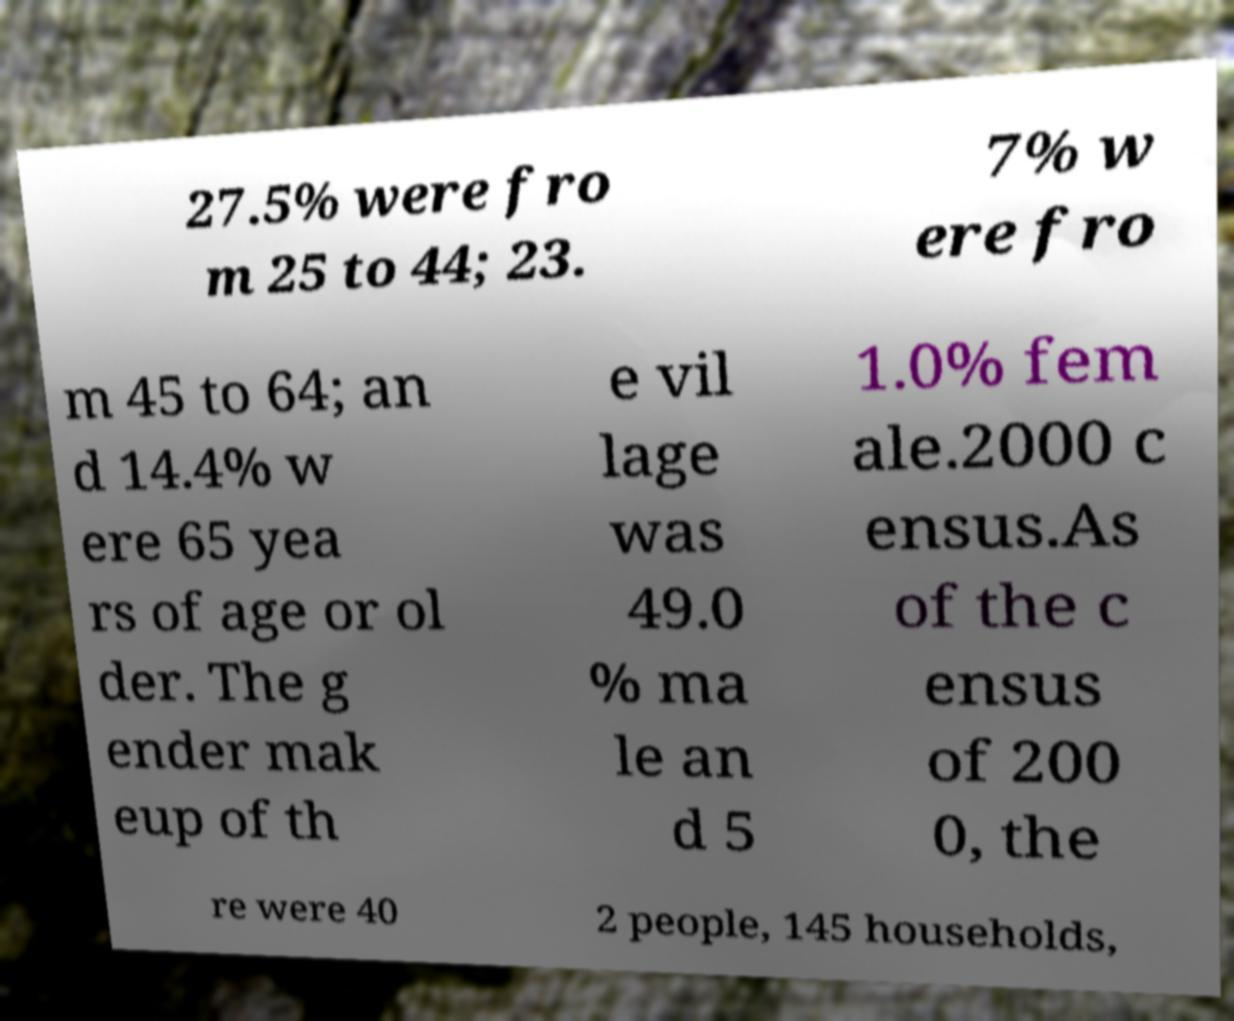Can you accurately transcribe the text from the provided image for me? 27.5% were fro m 25 to 44; 23. 7% w ere fro m 45 to 64; an d 14.4% w ere 65 yea rs of age or ol der. The g ender mak eup of th e vil lage was 49.0 % ma le an d 5 1.0% fem ale.2000 c ensus.As of the c ensus of 200 0, the re were 40 2 people, 145 households, 